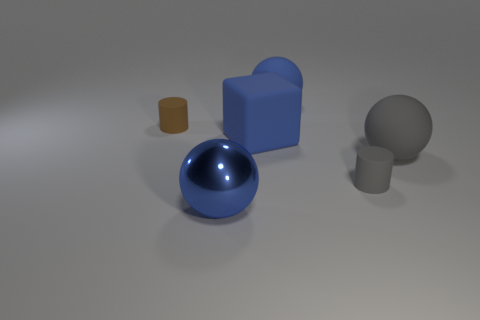Subtract all large rubber balls. How many balls are left? 1 Add 2 red spheres. How many red spheres exist? 2 Add 3 large blue things. How many objects exist? 9 Subtract all gray spheres. How many spheres are left? 2 Subtract 0 cyan balls. How many objects are left? 6 Subtract all cubes. How many objects are left? 5 Subtract 1 spheres. How many spheres are left? 2 Subtract all brown cubes. Subtract all brown spheres. How many cubes are left? 1 Subtract all blue balls. How many brown cylinders are left? 1 Subtract all small gray cubes. Subtract all blue rubber objects. How many objects are left? 4 